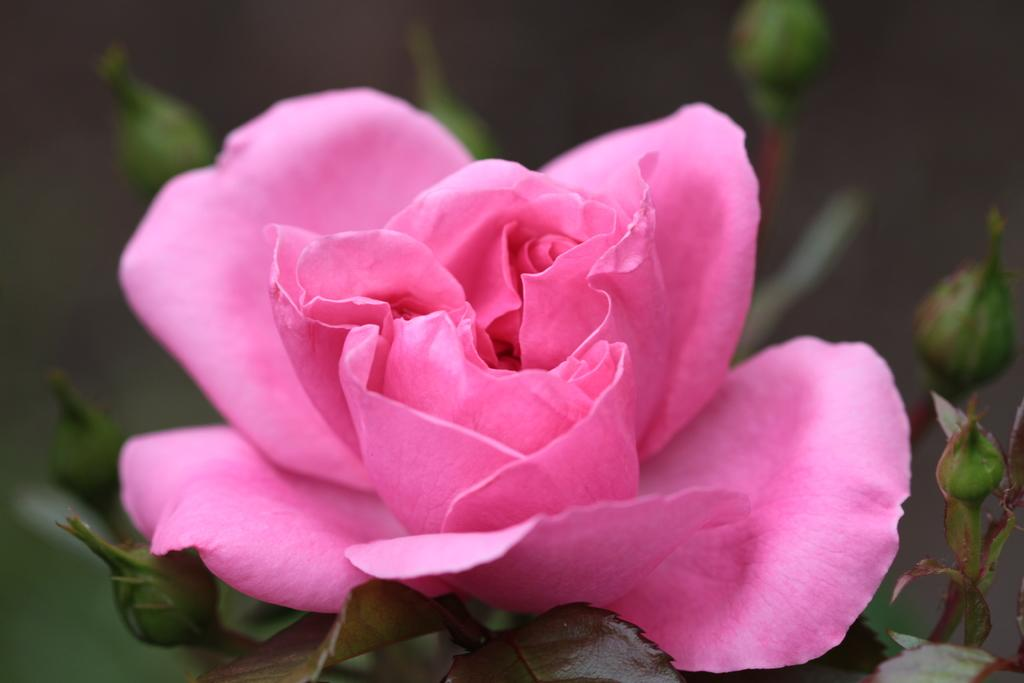What type of flower can be seen in the image? There is a pink color flower in the image. What stage of growth are the flowers on the plant in the image? There are buds on the plant in the image. Can you describe the background of the image? The background of the image is blurry. What type of cord is used to reward the flower in the image? There is no cord or reward system present in the image; it is a photograph of a flowering plant. 